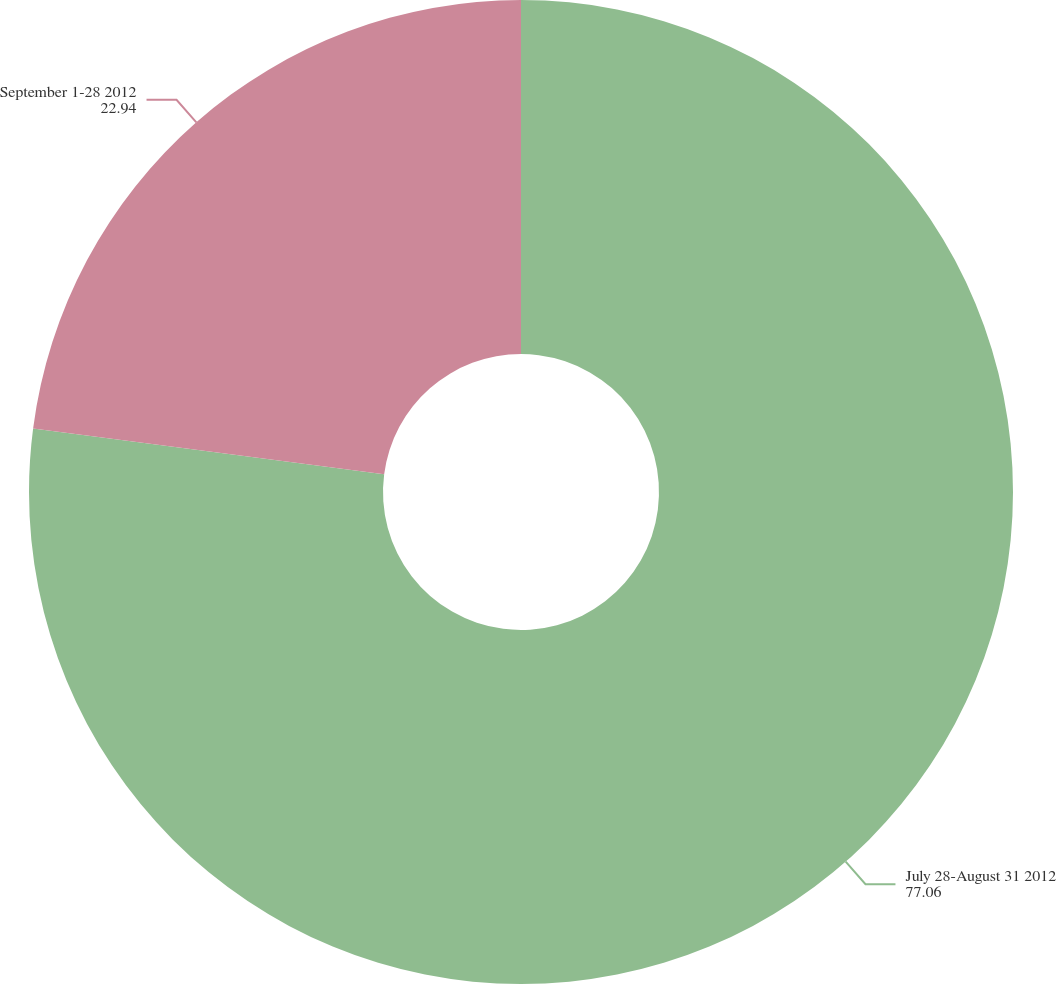Convert chart to OTSL. <chart><loc_0><loc_0><loc_500><loc_500><pie_chart><fcel>July 28-August 31 2012<fcel>September 1-28 2012<nl><fcel>77.06%<fcel>22.94%<nl></chart> 